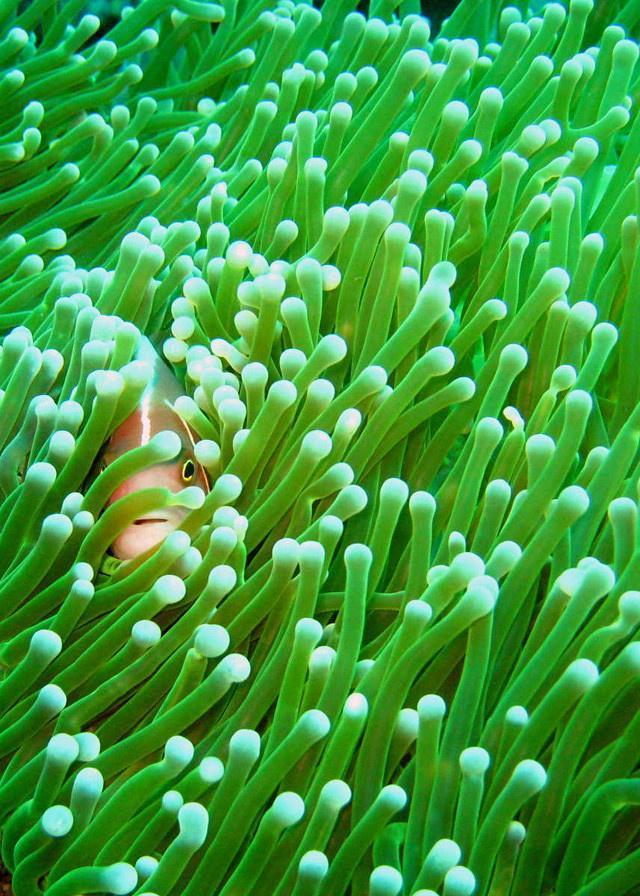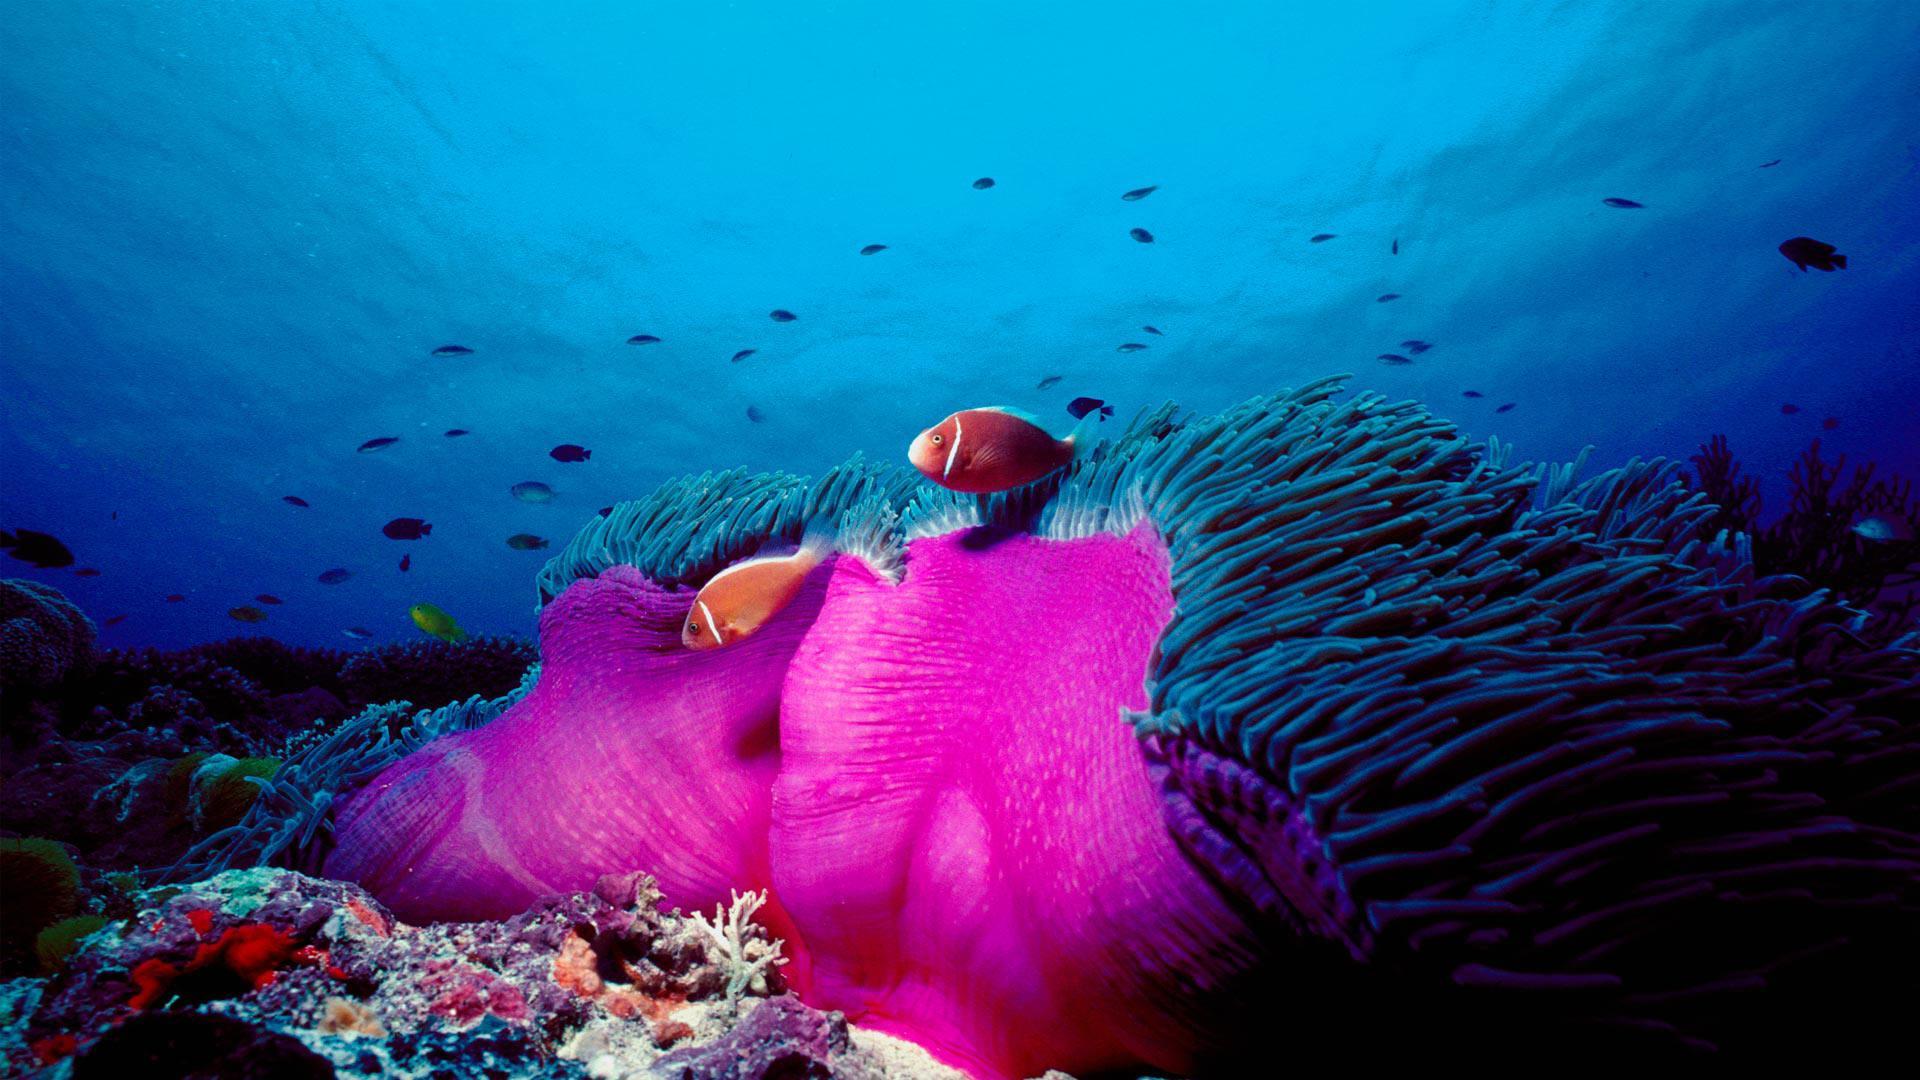The first image is the image on the left, the second image is the image on the right. Evaluate the accuracy of this statement regarding the images: "In at least one image there is a hot pink collar with an orange and pink fish swimming on top of it.". Is it true? Answer yes or no. Yes. The first image is the image on the left, the second image is the image on the right. Evaluate the accuracy of this statement regarding the images: "The left image contains a single fish.". Is it true? Answer yes or no. Yes. 